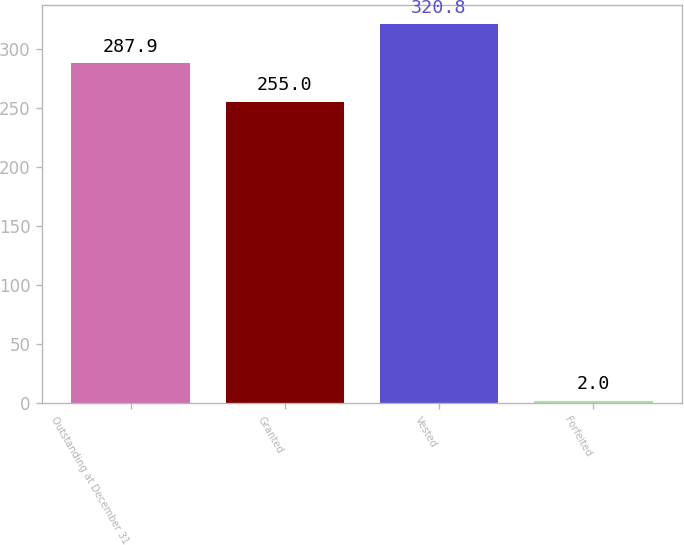Convert chart. <chart><loc_0><loc_0><loc_500><loc_500><bar_chart><fcel>Outstanding at December 31<fcel>Granted<fcel>Vested<fcel>Forfeited<nl><fcel>287.9<fcel>255<fcel>320.8<fcel>2<nl></chart> 